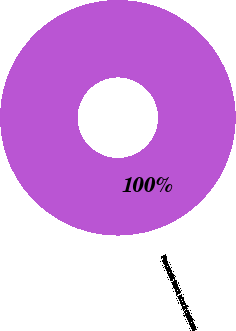Convert chart. <chart><loc_0><loc_0><loc_500><loc_500><pie_chart><fcel>Proceeds from stock options<nl><fcel>100.0%<nl></chart> 